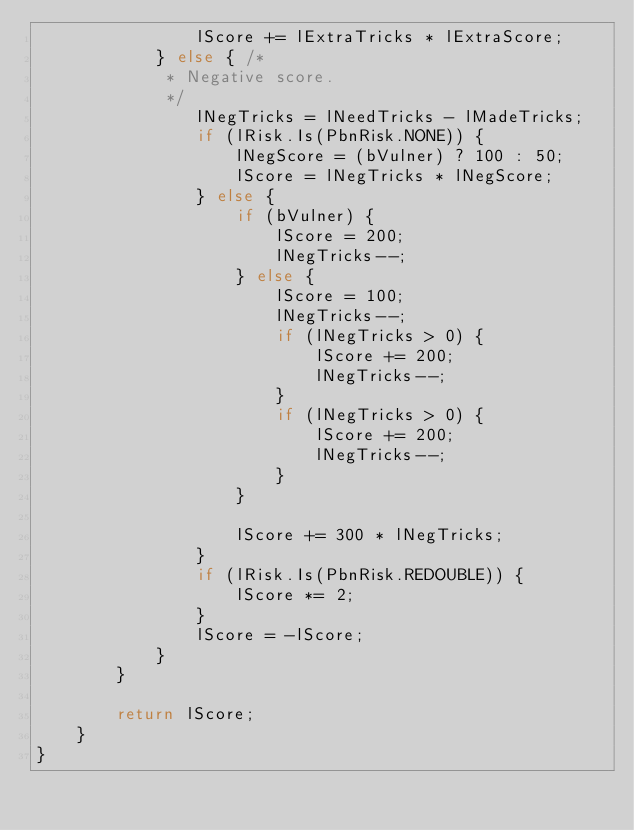Convert code to text. <code><loc_0><loc_0><loc_500><loc_500><_Java_>                lScore += lExtraTricks * lExtraScore;
            } else { /*
             * Negative score.
             */
                lNegTricks = lNeedTricks - lMadeTricks;
                if (lRisk.Is(PbnRisk.NONE)) {
                    lNegScore = (bVulner) ? 100 : 50;
                    lScore = lNegTricks * lNegScore;
                } else {
                    if (bVulner) {
                        lScore = 200;
                        lNegTricks--;
                    } else {
                        lScore = 100;
                        lNegTricks--;
                        if (lNegTricks > 0) {
                            lScore += 200;
                            lNegTricks--;
                        }
                        if (lNegTricks > 0) {
                            lScore += 200;
                            lNegTricks--;
                        }
                    }

                    lScore += 300 * lNegTricks;
                }
                if (lRisk.Is(PbnRisk.REDOUBLE)) {
                    lScore *= 2;
                }
                lScore = -lScore;
            }
        }

        return lScore;
    }
}
</code> 